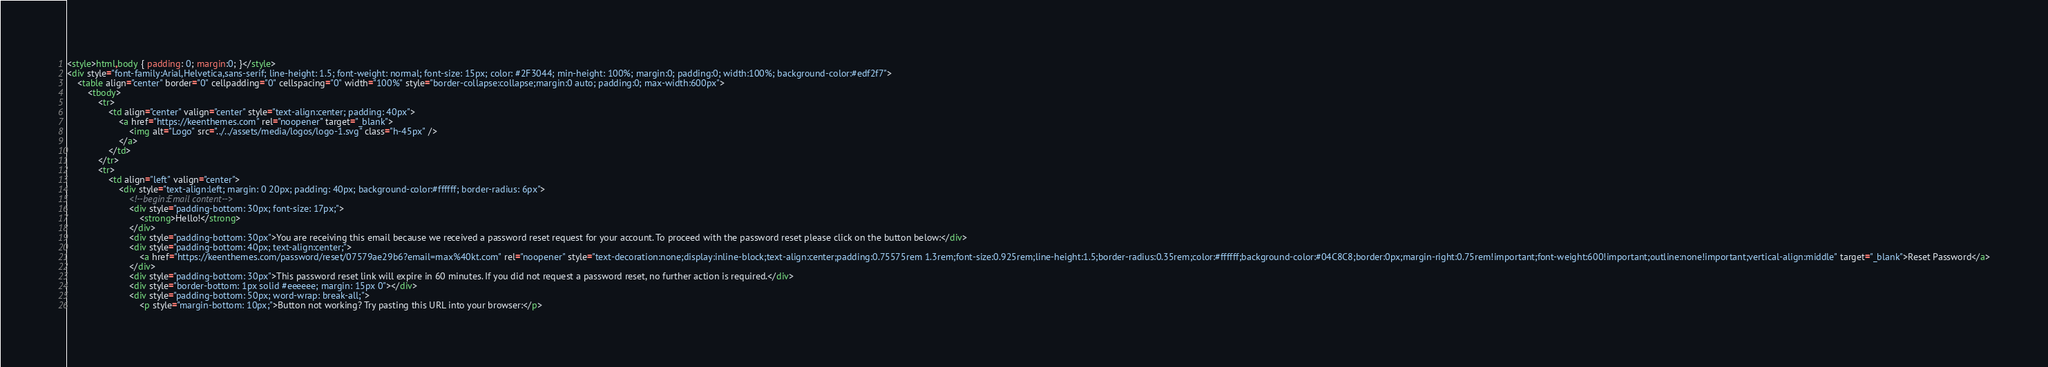<code> <loc_0><loc_0><loc_500><loc_500><_HTML_><style>html,body { padding: 0; margin:0; }</style>
<div style="font-family:Arial,Helvetica,sans-serif; line-height: 1.5; font-weight: normal; font-size: 15px; color: #2F3044; min-height: 100%; margin:0; padding:0; width:100%; background-color:#edf2f7">
	<table align="center" border="0" cellpadding="0" cellspacing="0" width="100%" style="border-collapse:collapse;margin:0 auto; padding:0; max-width:600px">
		<tbody>
			<tr>
				<td align="center" valign="center" style="text-align:center; padding: 40px">
					<a href="https://keenthemes.com" rel="noopener" target="_blank">
						<img alt="Logo" src="../../assets/media/logos/logo-1.svg" class="h-45px" />
					</a>
				</td>
			</tr>
			<tr>
				<td align="left" valign="center">
					<div style="text-align:left; margin: 0 20px; padding: 40px; background-color:#ffffff; border-radius: 6px">
						<!--begin:Email content-->
						<div style="padding-bottom: 30px; font-size: 17px;">
							<strong>Hello!</strong>
						</div>
						<div style="padding-bottom: 30px">You are receiving this email because we received a password reset request for your account. To proceed with the password reset please click on the button below:</div>
						<div style="padding-bottom: 40px; text-align:center;">
							<a href="https://keenthemes.com/password/reset/07579ae29b6?email=max%40kt.com" rel="noopener" style="text-decoration:none;display:inline-block;text-align:center;padding:0.75575rem 1.3rem;font-size:0.925rem;line-height:1.5;border-radius:0.35rem;color:#ffffff;background-color:#04C8C8;border:0px;margin-right:0.75rem!important;font-weight:600!important;outline:none!important;vertical-align:middle" target="_blank">Reset Password</a>
						</div>
						<div style="padding-bottom: 30px">This password reset link will expire in 60 minutes. If you did not request a password reset, no further action is required.</div>
						<div style="border-bottom: 1px solid #eeeeee; margin: 15px 0"></div>
						<div style="padding-bottom: 50px; word-wrap: break-all;">
							<p style="margin-bottom: 10px;">Button not working? Try pasting this URL into your browser:</p></code> 